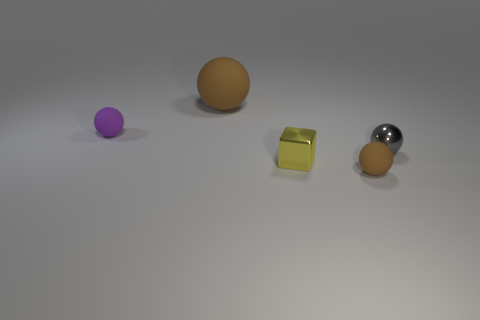Add 3 large green things. How many objects exist? 8 Subtract all balls. How many objects are left? 1 Add 1 small brown matte balls. How many small brown matte balls exist? 2 Subtract 0 yellow cylinders. How many objects are left? 5 Subtract all blocks. Subtract all metallic blocks. How many objects are left? 3 Add 3 large rubber spheres. How many large rubber spheres are left? 4 